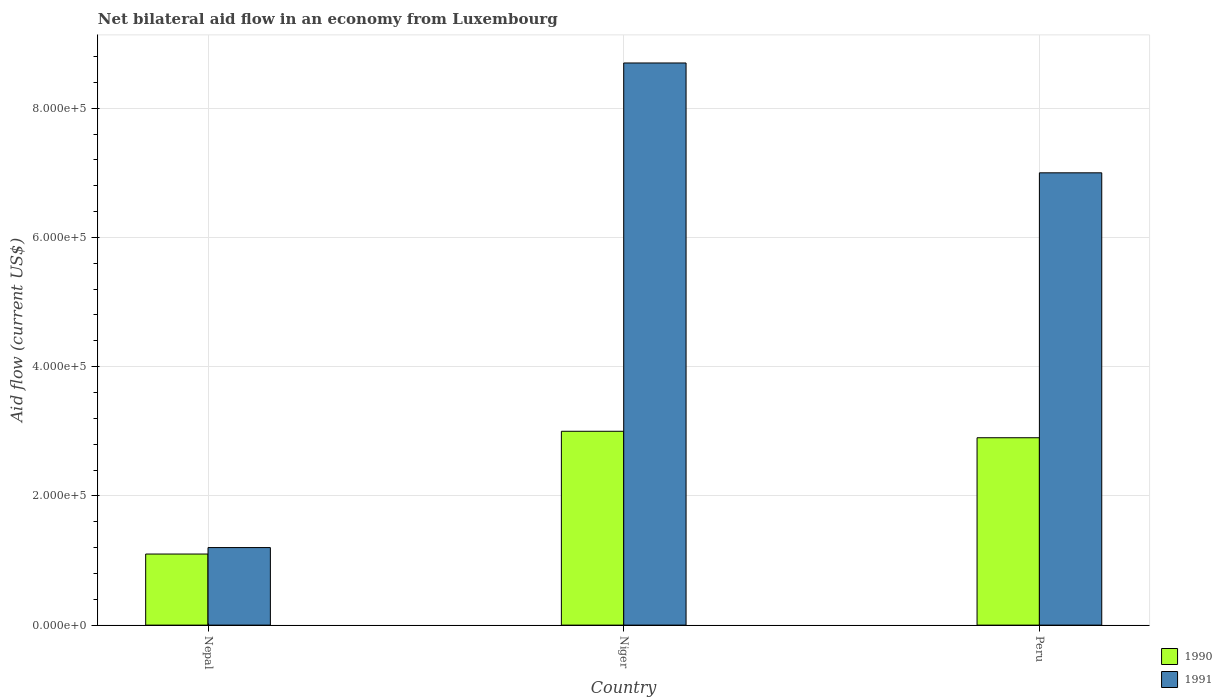How many groups of bars are there?
Provide a short and direct response. 3. What is the label of the 1st group of bars from the left?
Keep it short and to the point. Nepal. What is the net bilateral aid flow in 1990 in Peru?
Your response must be concise. 2.90e+05. Across all countries, what is the maximum net bilateral aid flow in 1990?
Make the answer very short. 3.00e+05. Across all countries, what is the minimum net bilateral aid flow in 1990?
Give a very brief answer. 1.10e+05. In which country was the net bilateral aid flow in 1991 maximum?
Keep it short and to the point. Niger. In which country was the net bilateral aid flow in 1991 minimum?
Provide a short and direct response. Nepal. What is the difference between the net bilateral aid flow in 1990 in Niger and the net bilateral aid flow in 1991 in Peru?
Provide a short and direct response. -4.00e+05. What is the average net bilateral aid flow in 1990 per country?
Your response must be concise. 2.33e+05. What is the ratio of the net bilateral aid flow in 1991 in Nepal to that in Peru?
Ensure brevity in your answer.  0.17. What is the difference between the highest and the lowest net bilateral aid flow in 1990?
Provide a succinct answer. 1.90e+05. In how many countries, is the net bilateral aid flow in 1990 greater than the average net bilateral aid flow in 1990 taken over all countries?
Your response must be concise. 2. Is the sum of the net bilateral aid flow in 1991 in Nepal and Peru greater than the maximum net bilateral aid flow in 1990 across all countries?
Make the answer very short. Yes. How many bars are there?
Offer a very short reply. 6. Are all the bars in the graph horizontal?
Your answer should be very brief. No. How many countries are there in the graph?
Your answer should be compact. 3. Are the values on the major ticks of Y-axis written in scientific E-notation?
Your response must be concise. Yes. Does the graph contain any zero values?
Your answer should be very brief. No. Where does the legend appear in the graph?
Your answer should be compact. Bottom right. How many legend labels are there?
Your response must be concise. 2. What is the title of the graph?
Give a very brief answer. Net bilateral aid flow in an economy from Luxembourg. What is the label or title of the X-axis?
Keep it short and to the point. Country. What is the Aid flow (current US$) in 1990 in Nepal?
Keep it short and to the point. 1.10e+05. What is the Aid flow (current US$) in 1991 in Niger?
Your answer should be very brief. 8.70e+05. Across all countries, what is the maximum Aid flow (current US$) in 1990?
Make the answer very short. 3.00e+05. Across all countries, what is the maximum Aid flow (current US$) of 1991?
Your answer should be compact. 8.70e+05. Across all countries, what is the minimum Aid flow (current US$) of 1990?
Give a very brief answer. 1.10e+05. What is the total Aid flow (current US$) of 1991 in the graph?
Provide a short and direct response. 1.69e+06. What is the difference between the Aid flow (current US$) in 1991 in Nepal and that in Niger?
Provide a short and direct response. -7.50e+05. What is the difference between the Aid flow (current US$) in 1991 in Nepal and that in Peru?
Make the answer very short. -5.80e+05. What is the difference between the Aid flow (current US$) of 1990 in Niger and that in Peru?
Offer a very short reply. 10000. What is the difference between the Aid flow (current US$) of 1990 in Nepal and the Aid flow (current US$) of 1991 in Niger?
Keep it short and to the point. -7.60e+05. What is the difference between the Aid flow (current US$) in 1990 in Nepal and the Aid flow (current US$) in 1991 in Peru?
Keep it short and to the point. -5.90e+05. What is the difference between the Aid flow (current US$) of 1990 in Niger and the Aid flow (current US$) of 1991 in Peru?
Your response must be concise. -4.00e+05. What is the average Aid flow (current US$) in 1990 per country?
Your answer should be compact. 2.33e+05. What is the average Aid flow (current US$) of 1991 per country?
Provide a succinct answer. 5.63e+05. What is the difference between the Aid flow (current US$) in 1990 and Aid flow (current US$) in 1991 in Nepal?
Provide a short and direct response. -10000. What is the difference between the Aid flow (current US$) of 1990 and Aid flow (current US$) of 1991 in Niger?
Your response must be concise. -5.70e+05. What is the difference between the Aid flow (current US$) of 1990 and Aid flow (current US$) of 1991 in Peru?
Offer a very short reply. -4.10e+05. What is the ratio of the Aid flow (current US$) of 1990 in Nepal to that in Niger?
Your answer should be compact. 0.37. What is the ratio of the Aid flow (current US$) of 1991 in Nepal to that in Niger?
Provide a succinct answer. 0.14. What is the ratio of the Aid flow (current US$) of 1990 in Nepal to that in Peru?
Make the answer very short. 0.38. What is the ratio of the Aid flow (current US$) in 1991 in Nepal to that in Peru?
Provide a short and direct response. 0.17. What is the ratio of the Aid flow (current US$) of 1990 in Niger to that in Peru?
Offer a very short reply. 1.03. What is the ratio of the Aid flow (current US$) of 1991 in Niger to that in Peru?
Ensure brevity in your answer.  1.24. What is the difference between the highest and the second highest Aid flow (current US$) in 1990?
Make the answer very short. 10000. What is the difference between the highest and the lowest Aid flow (current US$) in 1990?
Your answer should be very brief. 1.90e+05. What is the difference between the highest and the lowest Aid flow (current US$) of 1991?
Provide a succinct answer. 7.50e+05. 